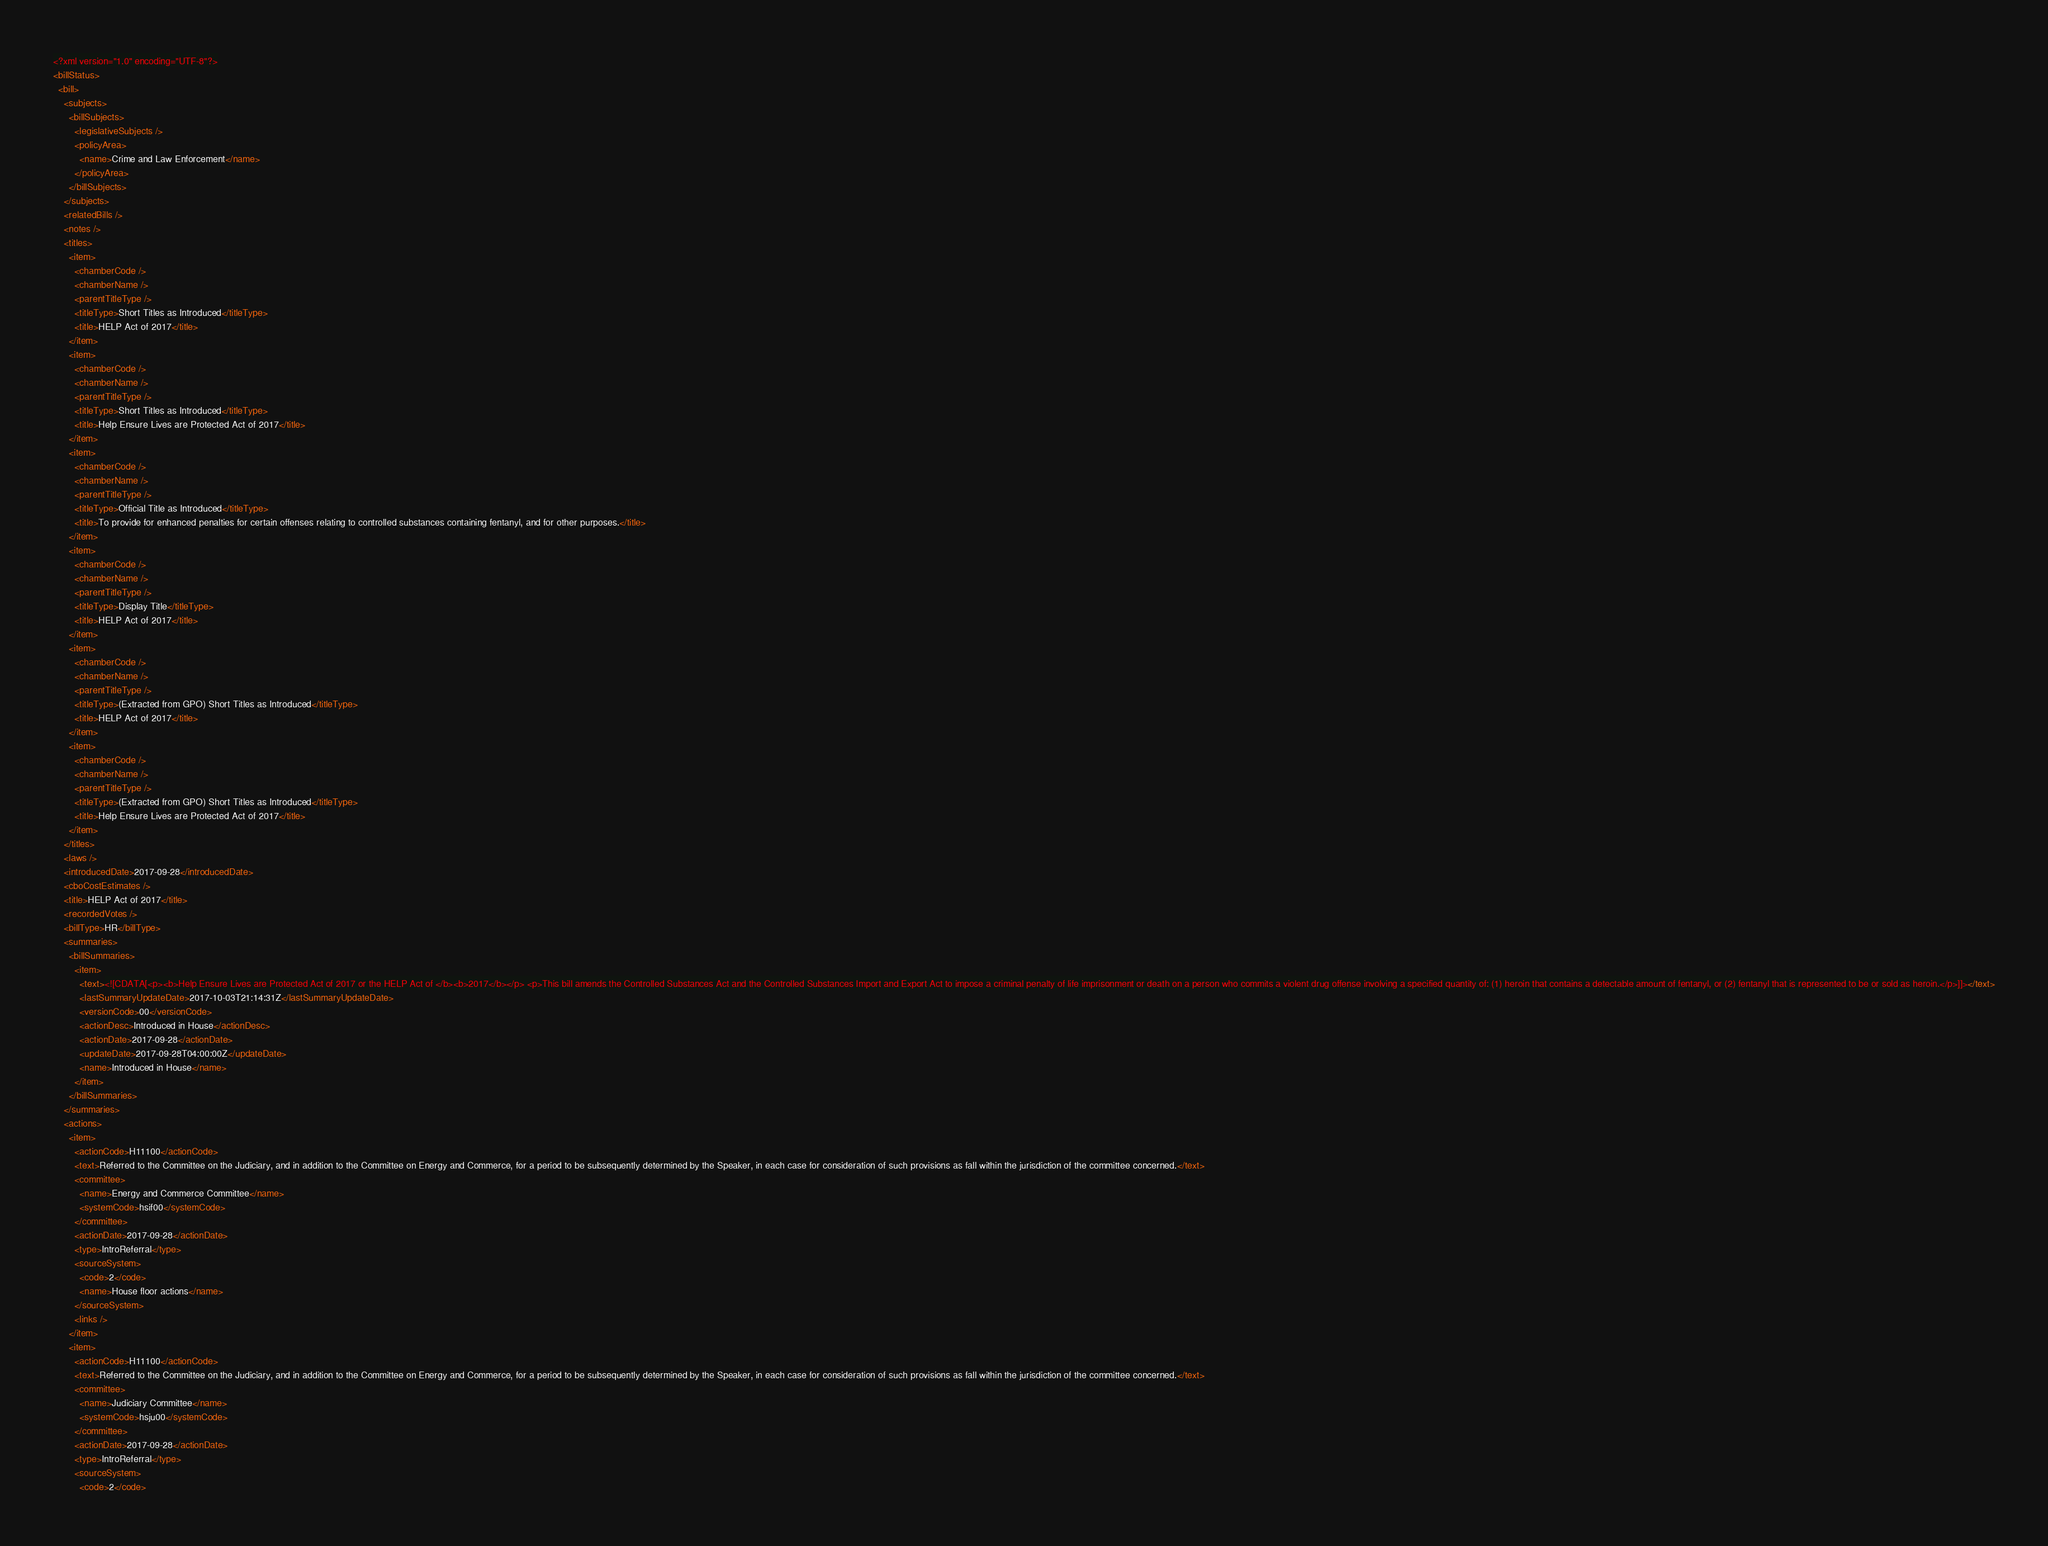<code> <loc_0><loc_0><loc_500><loc_500><_XML_><?xml version="1.0" encoding="UTF-8"?>
<billStatus>
  <bill>
    <subjects>
      <billSubjects>
        <legislativeSubjects />
        <policyArea>
          <name>Crime and Law Enforcement</name>
        </policyArea>
      </billSubjects>
    </subjects>
    <relatedBills />
    <notes />
    <titles>
      <item>
        <chamberCode />
        <chamberName />
        <parentTitleType />
        <titleType>Short Titles as Introduced</titleType>
        <title>HELP Act of 2017</title>
      </item>
      <item>
        <chamberCode />
        <chamberName />
        <parentTitleType />
        <titleType>Short Titles as Introduced</titleType>
        <title>Help Ensure Lives are Protected Act of 2017</title>
      </item>
      <item>
        <chamberCode />
        <chamberName />
        <parentTitleType />
        <titleType>Official Title as Introduced</titleType>
        <title>To provide for enhanced penalties for certain offenses relating to controlled substances containing fentanyl, and for other purposes.</title>
      </item>
      <item>
        <chamberCode />
        <chamberName />
        <parentTitleType />
        <titleType>Display Title</titleType>
        <title>HELP Act of 2017</title>
      </item>
      <item>
        <chamberCode />
        <chamberName />
        <parentTitleType />
        <titleType>(Extracted from GPO) Short Titles as Introduced</titleType>
        <title>HELP Act of 2017</title>
      </item>
      <item>
        <chamberCode />
        <chamberName />
        <parentTitleType />
        <titleType>(Extracted from GPO) Short Titles as Introduced</titleType>
        <title>Help Ensure Lives are Protected Act of 2017</title>
      </item>
    </titles>
    <laws />
    <introducedDate>2017-09-28</introducedDate>
    <cboCostEstimates />
    <title>HELP Act of 2017</title>
    <recordedVotes />
    <billType>HR</billType>
    <summaries>
      <billSummaries>
        <item>
          <text><![CDATA[<p><b>Help Ensure Lives are Protected Act of 2017 or the HELP Act of </b><b>2017</b></p> <p>This bill amends the Controlled Substances Act and the Controlled Substances Import and Export Act to impose a criminal penalty of life imprisonment or death on a person who commits a violent drug offense involving a specified quantity of: (1) heroin that contains a detectable amount of fentanyl, or (2) fentanyl that is represented to be or sold as heroin.</p>]]></text>
          <lastSummaryUpdateDate>2017-10-03T21:14:31Z</lastSummaryUpdateDate>
          <versionCode>00</versionCode>
          <actionDesc>Introduced in House</actionDesc>
          <actionDate>2017-09-28</actionDate>
          <updateDate>2017-09-28T04:00:00Z</updateDate>
          <name>Introduced in House</name>
        </item>
      </billSummaries>
    </summaries>
    <actions>
      <item>
        <actionCode>H11100</actionCode>
        <text>Referred to the Committee on the Judiciary, and in addition to the Committee on Energy and Commerce, for a period to be subsequently determined by the Speaker, in each case for consideration of such provisions as fall within the jurisdiction of the committee concerned.</text>
        <committee>
          <name>Energy and Commerce Committee</name>
          <systemCode>hsif00</systemCode>
        </committee>
        <actionDate>2017-09-28</actionDate>
        <type>IntroReferral</type>
        <sourceSystem>
          <code>2</code>
          <name>House floor actions</name>
        </sourceSystem>
        <links />
      </item>
      <item>
        <actionCode>H11100</actionCode>
        <text>Referred to the Committee on the Judiciary, and in addition to the Committee on Energy and Commerce, for a period to be subsequently determined by the Speaker, in each case for consideration of such provisions as fall within the jurisdiction of the committee concerned.</text>
        <committee>
          <name>Judiciary Committee</name>
          <systemCode>hsju00</systemCode>
        </committee>
        <actionDate>2017-09-28</actionDate>
        <type>IntroReferral</type>
        <sourceSystem>
          <code>2</code></code> 